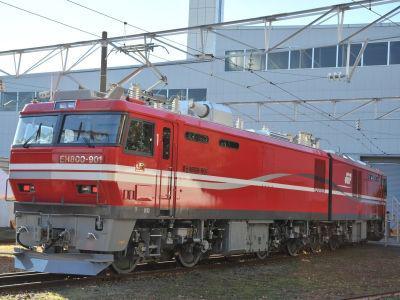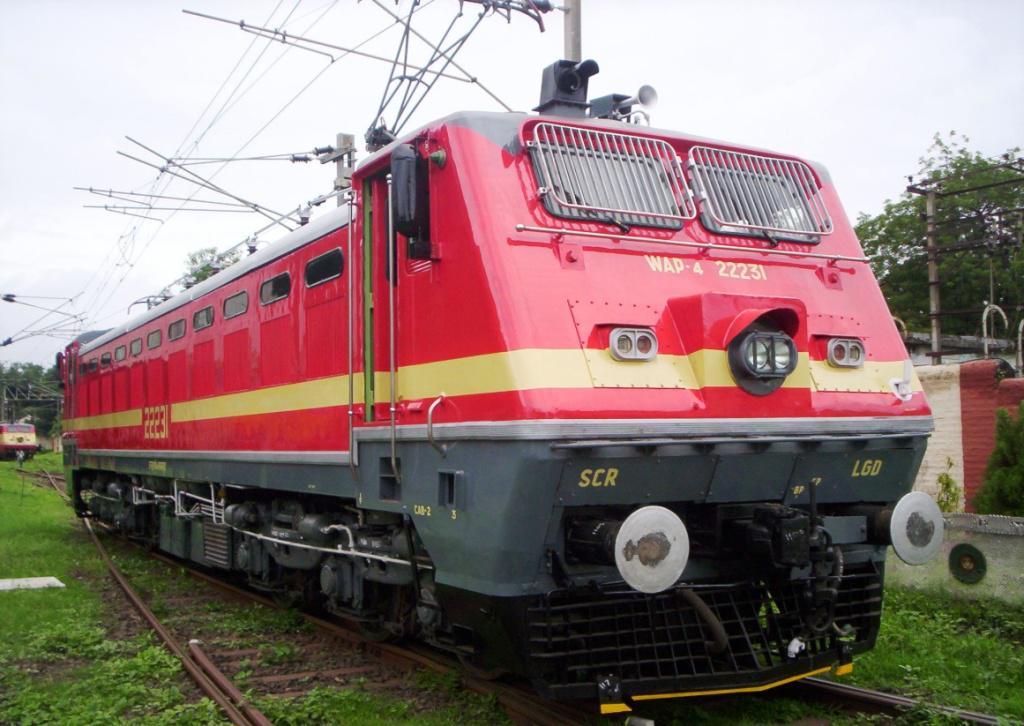The first image is the image on the left, the second image is the image on the right. Evaluate the accuracy of this statement regarding the images: "Trains in right and left images are true red and face different directions.". Is it true? Answer yes or no. Yes. The first image is the image on the left, the second image is the image on the right. Examine the images to the left and right. Is the description "There is exactly one power pole in the image on the left" accurate? Answer yes or no. Yes. 